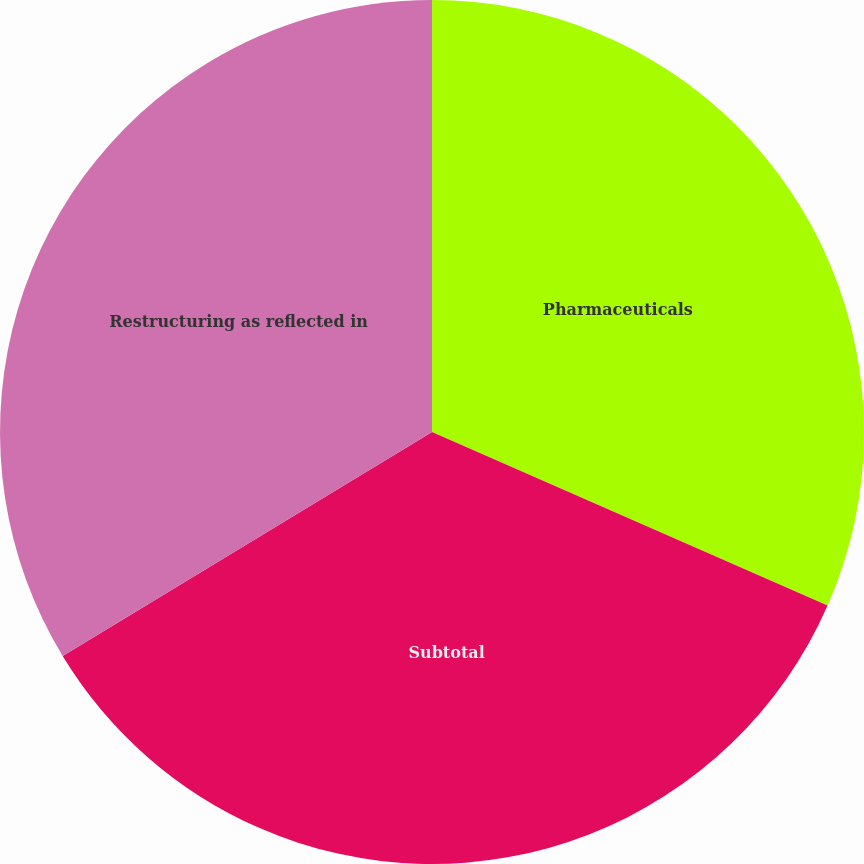<chart> <loc_0><loc_0><loc_500><loc_500><pie_chart><fcel>Pharmaceuticals<fcel>Subtotal<fcel>Restructuring as reflected in<nl><fcel>31.58%<fcel>34.74%<fcel>33.68%<nl></chart> 